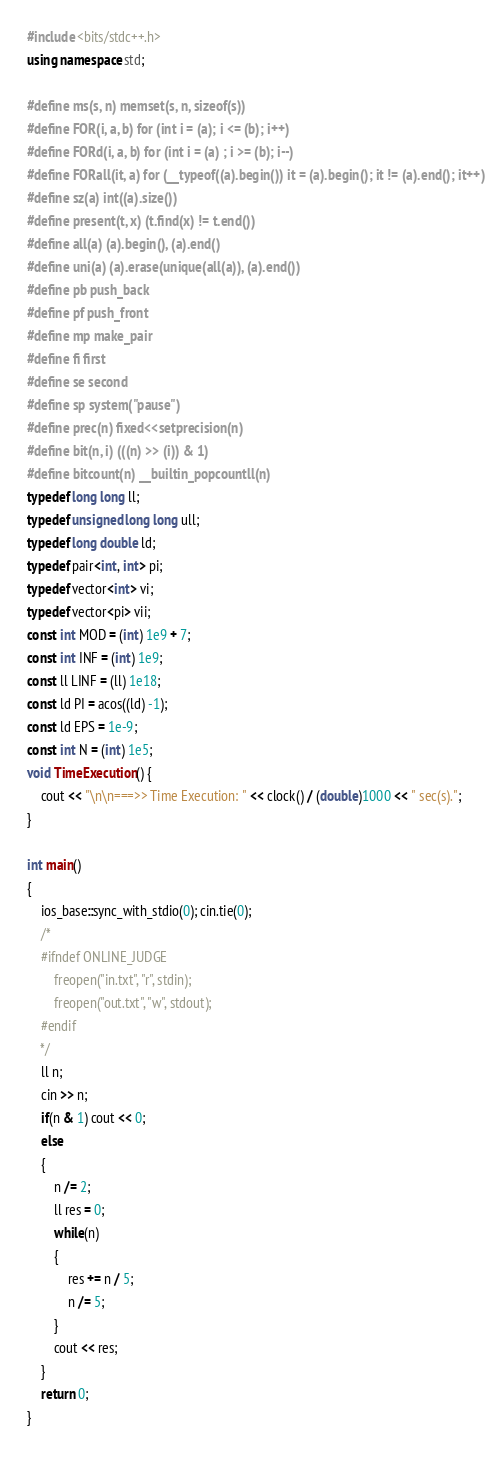<code> <loc_0><loc_0><loc_500><loc_500><_C++_>#include <bits/stdc++.h>
using namespace std;

#define ms(s, n) memset(s, n, sizeof(s))
#define FOR(i, a, b) for (int i = (a); i <= (b); i++)
#define FORd(i, a, b) for (int i = (a) ; i >= (b); i--)
#define FORall(it, a) for (__typeof((a).begin()) it = (a).begin(); it != (a).end(); it++)
#define sz(a) int((a).size())
#define present(t, x) (t.find(x) != t.end())
#define all(a) (a).begin(), (a).end()
#define uni(a) (a).erase(unique(all(a)), (a).end())
#define pb push_back
#define pf push_front
#define mp make_pair
#define fi first
#define se second
#define sp system("pause")
#define prec(n) fixed<<setprecision(n)
#define bit(n, i) (((n) >> (i)) & 1)
#define bitcount(n) __builtin_popcountll(n)
typedef long long ll;
typedef unsigned long long ull;
typedef long double ld;
typedef pair<int, int> pi;
typedef vector<int> vi;
typedef vector<pi> vii;
const int MOD = (int) 1e9 + 7;
const int INF = (int) 1e9;
const ll LINF = (ll) 1e18;
const ld PI = acos((ld) -1);
const ld EPS = 1e-9;
const int N = (int) 1e5;
void TimeExecution() {
    cout << "\n\n===>> Time Execution: " << clock() / (double)1000 << " sec(s).";
}

int main()
{
    ios_base::sync_with_stdio(0); cin.tie(0);
    /*
    #ifndef ONLINE_JUDGE
        freopen("in.txt", "r", stdin);
        freopen("out.txt", "w", stdout);
    #endif
    */
    ll n;
    cin >> n;
    if(n & 1) cout << 0;
    else
    {
        n /= 2;
        ll res = 0;
        while(n)
        {
            res += n / 5;
            n /= 5;
        }
        cout << res;
    }
    return 0;
}
</code> 